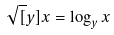Convert formula to latex. <formula><loc_0><loc_0><loc_500><loc_500>\sqrt { [ } y ] { x } = \log _ { y } x</formula> 